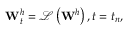Convert formula to latex. <formula><loc_0><loc_0><loc_500><loc_500>W _ { t } ^ { h } = \mathcal { L } \left ( { { W } ^ { h } } \right ) , t = { { t } _ { n } } ,</formula> 